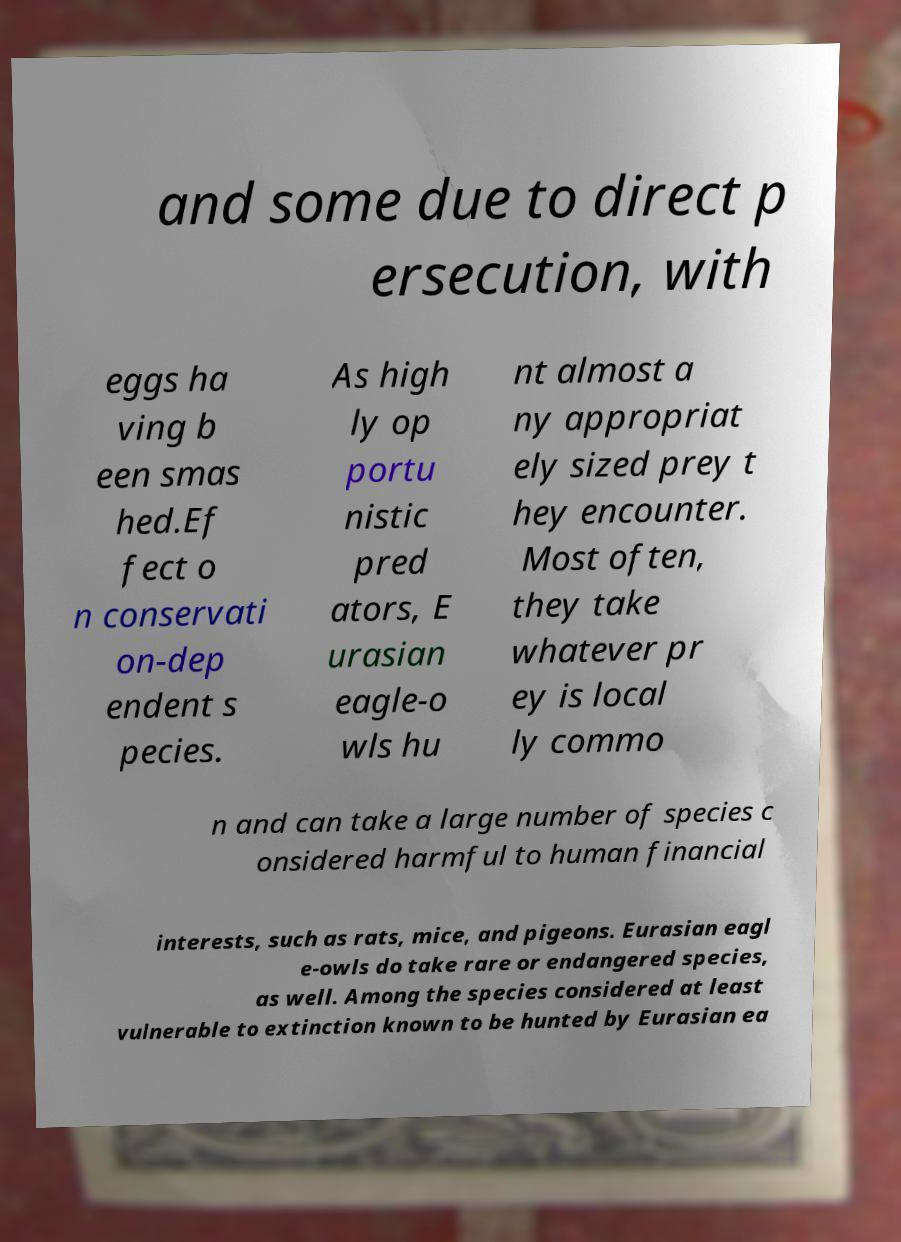There's text embedded in this image that I need extracted. Can you transcribe it verbatim? and some due to direct p ersecution, with eggs ha ving b een smas hed.Ef fect o n conservati on-dep endent s pecies. As high ly op portu nistic pred ators, E urasian eagle-o wls hu nt almost a ny appropriat ely sized prey t hey encounter. Most often, they take whatever pr ey is local ly commo n and can take a large number of species c onsidered harmful to human financial interests, such as rats, mice, and pigeons. Eurasian eagl e-owls do take rare or endangered species, as well. Among the species considered at least vulnerable to extinction known to be hunted by Eurasian ea 